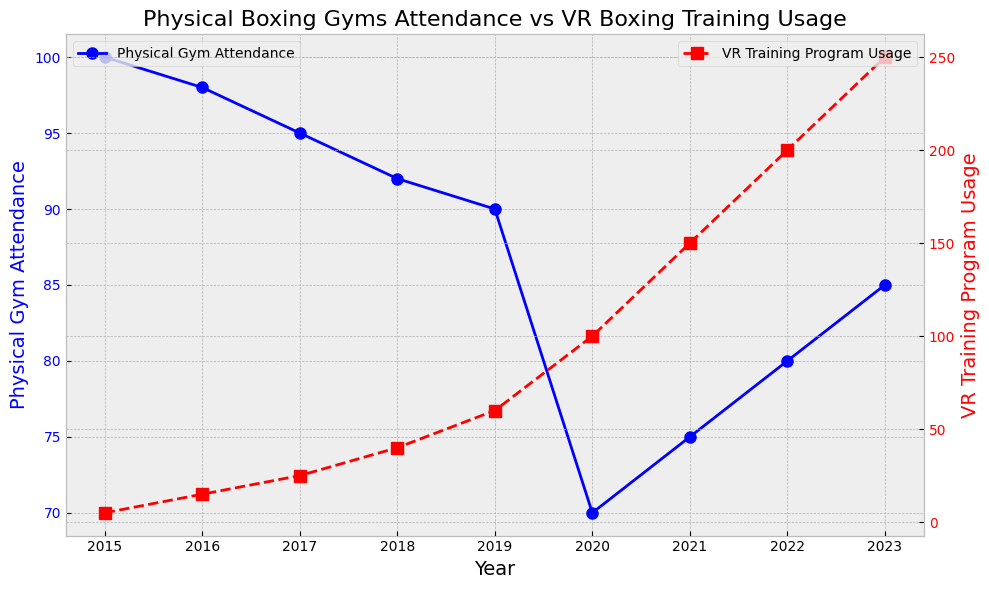What is the trend in Physical Gym Attendance from 2015 to 2023? To identify the trend in Physical Gym Attendance, look at the blue line on the graph from 2015 to 2023. The attendance starts at 100 in 2015, decreases steadily to 70 by 2020, then rises back up to 85 by 2023. This shows an initial decline followed by a recovery.
Answer: initial decline, then recovery How does the VR Training Program Usage compare between 2015 and 2023? To compare VR Training Program Usage between 2015 and 2023, observe the red line's values at these points. In 2015, the usage is at 5, and by 2023 it has increased significantly to 250.
Answer: increased from 5 to 250 What is the difference in Physical Gym Attendance between its lowest and highest value from 2015 to 2023? Identify the lowest (70 in 2020) and highest (100 in 2015) values from the blue line, then calculate the difference: 100 - 70.
Answer: 30 In which year did VR Training Program Usage surpass Physical Gym Attendance, and what were the respective values? Look for the intersection of the blue and red lines. In 2020, the red line (100) surpasses the blue line (70).
Answer: 2020, 100 vs 70 What was the average Physical Gym Attendance from 2015 to 2023? Add all values of Physical Gym Attendance (100 + 98 + 95 + 92 + 90 + 70 + 75 + 80 + 85) and divide by the number of years (9). Calculation: (785) / 9.
Answer: 87.22 How did the Physical Gym Attendance change from 2019 to 2020 and how does it compare to the change in VR Training Program Usage in the same period? Observe the values for 2019 and 2020 for Physical Gym Attendance (90 to 70, a decrease of 20) and VR Training Program Usage (60 to 100, an increase of 40).
Answer: Attendance decreased by 20, Usage increased by 40 What is the compound annual growth rate (CAGR) of VR Training Program Usage from 2015 to 2023? Using the formula CAGR = (End Value/Start Value)^(1/Number of Years) - 1. Here, End Value = 250, Start Value = 5, Number of Years = 8. Calculation: (250/5)^(1/8) - 1.
Answer: 58.62% Which year saw the highest year-over-year increase in VR Training Program Usage, and what was the increase? Find the year with the largest jump in the red line. The largest increase is from 2020 to 2021 (100 to 150), an increase of 50.
Answer: 2021, increased by 50 By how much did Physical Gym Attendance increase from its lowest point in 2020 to 2023? Subtract the 2020 value from the 2023 value: 85 - 70.
Answer: increased by 15 